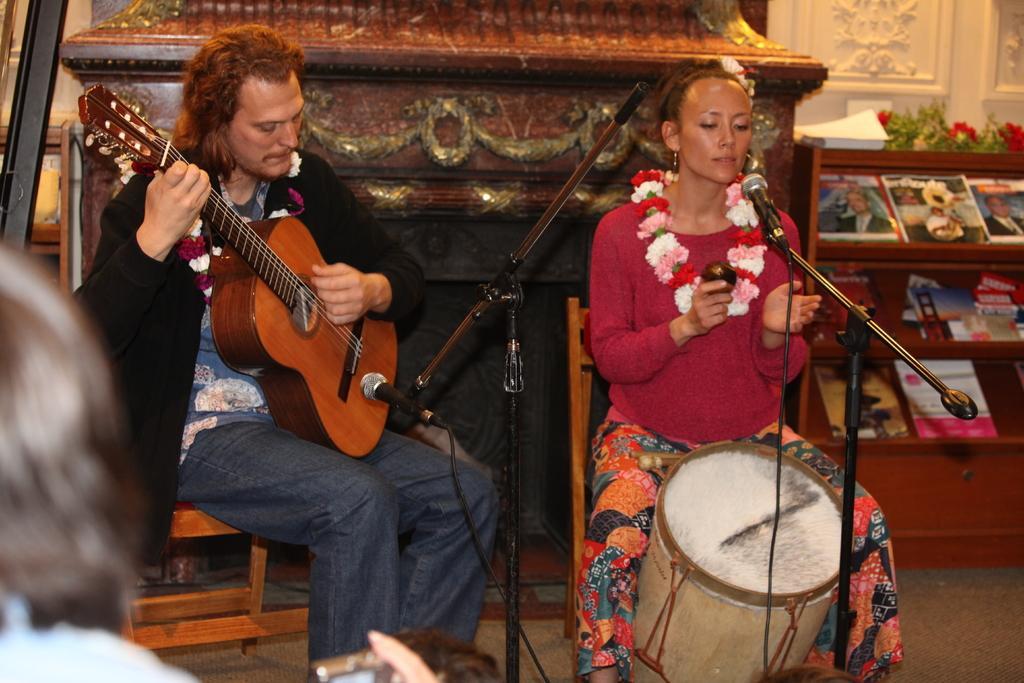Please provide a concise description of this image. In this image i can see there are two persons sitting on the chair. On the left side of the image we can see a man who is playing a guitar in his hands in front of the microphone and on the right side of the image we can see a woman is playing a musical instrument in front of the microphone. In the back of the image we can see there is a shelf in which it has couple of books. 